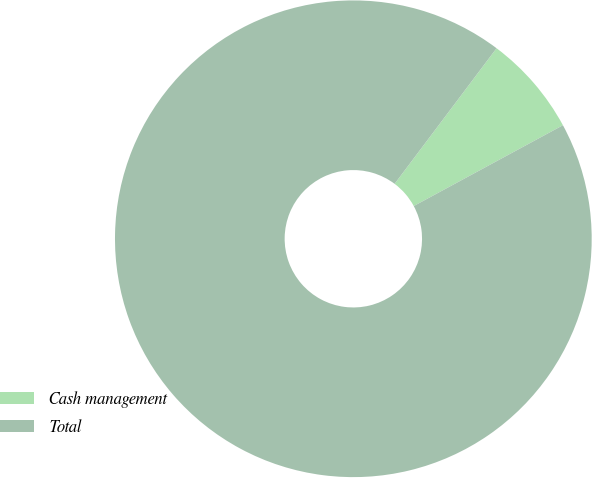Convert chart to OTSL. <chart><loc_0><loc_0><loc_500><loc_500><pie_chart><fcel>Cash management<fcel>Total<nl><fcel>6.84%<fcel>93.16%<nl></chart> 